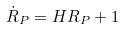<formula> <loc_0><loc_0><loc_500><loc_500>\dot { R } _ { P } = H R _ { P } + 1</formula> 